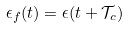Convert formula to latex. <formula><loc_0><loc_0><loc_500><loc_500>\epsilon _ { f } ( t ) = \epsilon ( t + \mathcal { T } _ { c } )</formula> 